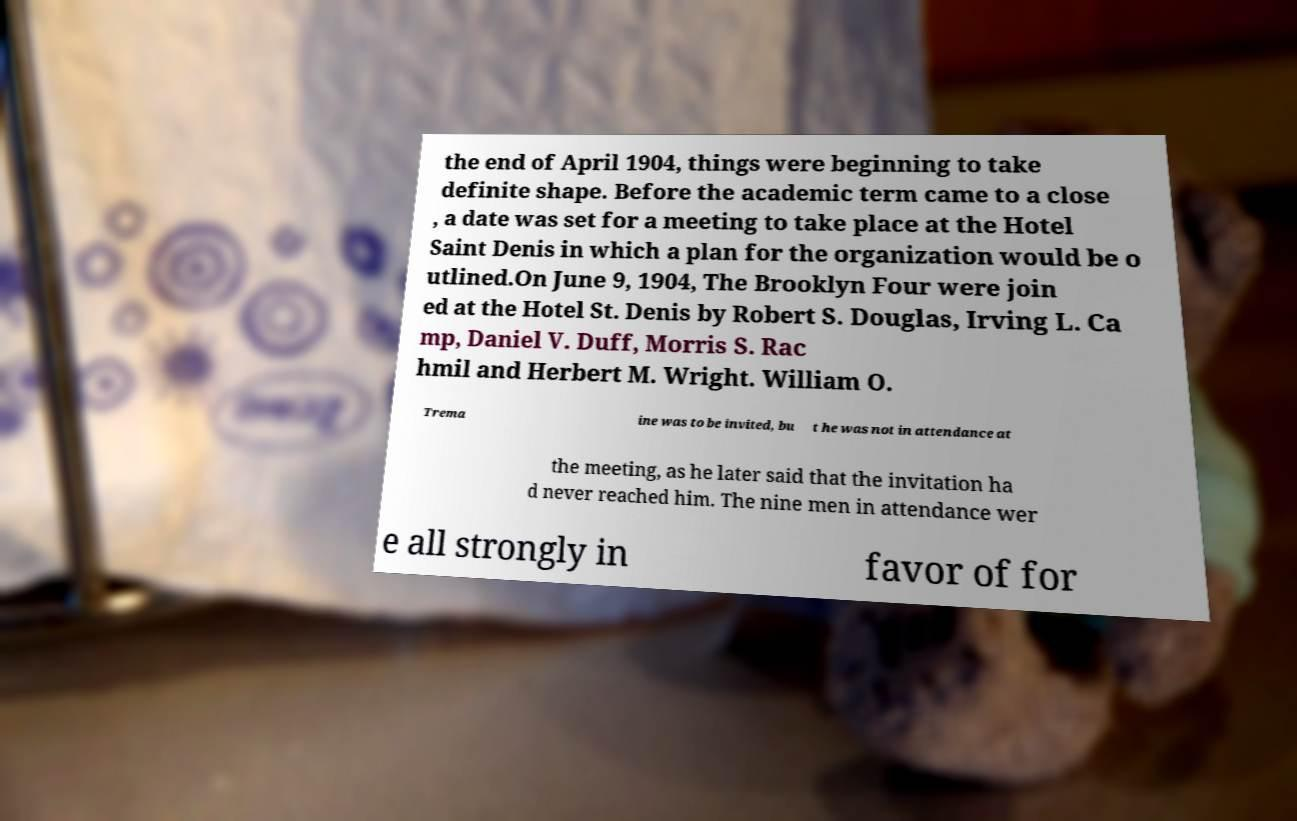Please identify and transcribe the text found in this image. the end of April 1904, things were beginning to take definite shape. Before the academic term came to a close , a date was set for a meeting to take place at the Hotel Saint Denis in which a plan for the organization would be o utlined.On June 9, 1904, The Brooklyn Four were join ed at the Hotel St. Denis by Robert S. Douglas, Irving L. Ca mp, Daniel V. Duff, Morris S. Rac hmil and Herbert M. Wright. William O. Trema ine was to be invited, bu t he was not in attendance at the meeting, as he later said that the invitation ha d never reached him. The nine men in attendance wer e all strongly in favor of for 